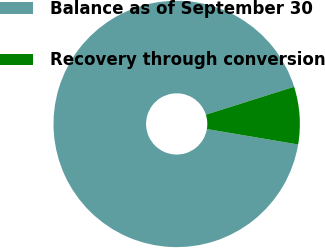<chart> <loc_0><loc_0><loc_500><loc_500><pie_chart><fcel>Balance as of September 30<fcel>Recovery through conversion<nl><fcel>92.45%<fcel>7.55%<nl></chart> 